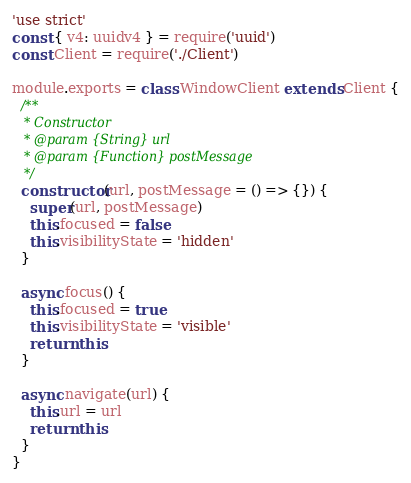<code> <loc_0><loc_0><loc_500><loc_500><_JavaScript_>'use strict'
const { v4: uuidv4 } = require('uuid')
const Client = require('./Client')

module.exports = class WindowClient extends Client {
  /**
   * Constructor
   * @param {String} url
   * @param {Function} postMessage
   */
  constructor(url, postMessage = () => {}) {
    super(url, postMessage)
    this.focused = false
    this.visibilityState = 'hidden'
  }

  async focus() {
    this.focused = true
    this.visibilityState = 'visible'
    return this
  }

  async navigate(url) {
    this.url = url
    return this
  }
}
</code> 